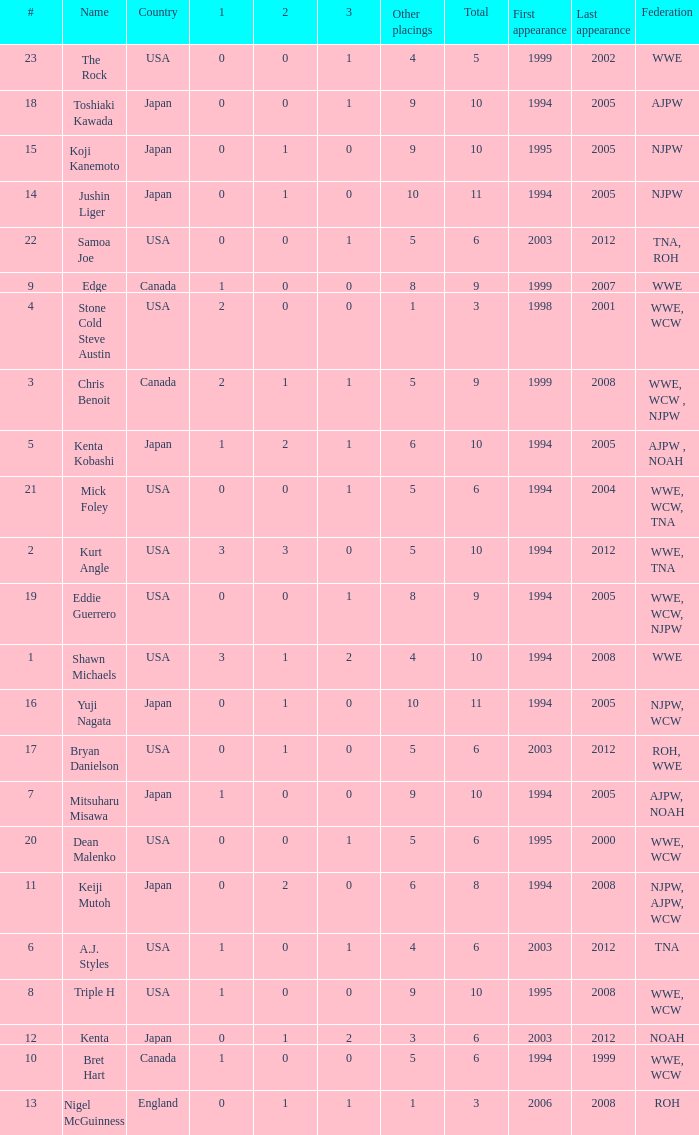What countries does the Rock come from? 1.0. 